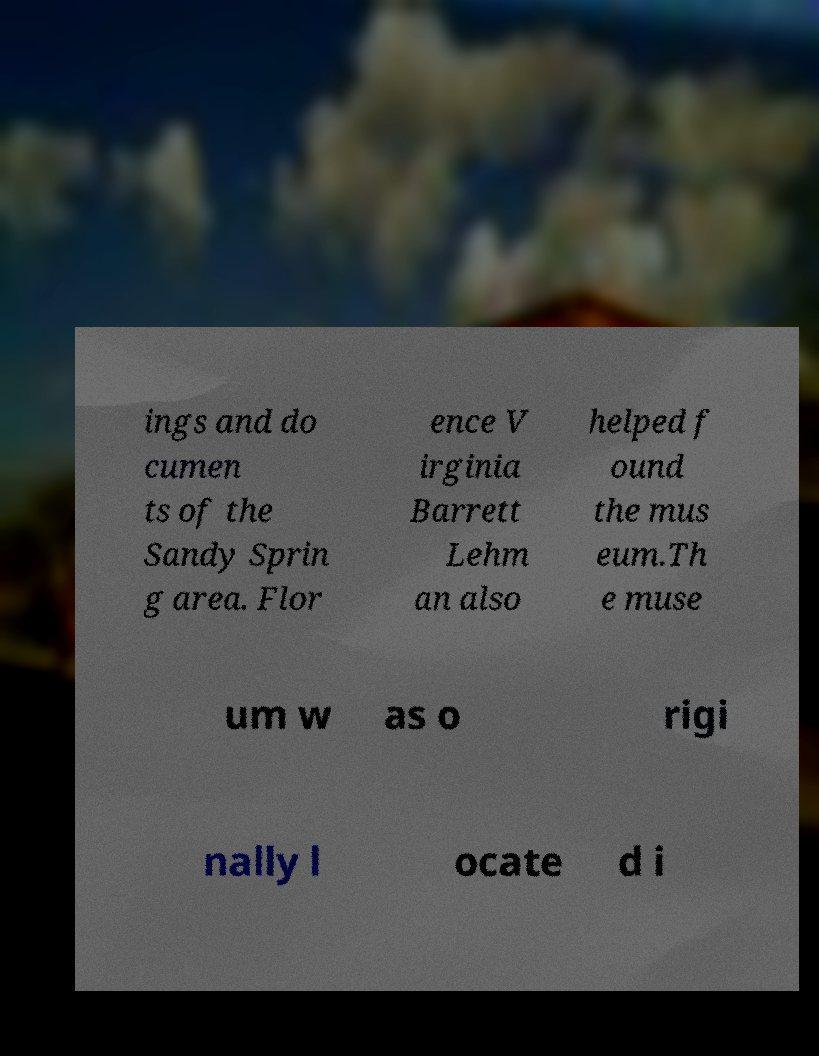Can you accurately transcribe the text from the provided image for me? ings and do cumen ts of the Sandy Sprin g area. Flor ence V irginia Barrett Lehm an also helped f ound the mus eum.Th e muse um w as o rigi nally l ocate d i 